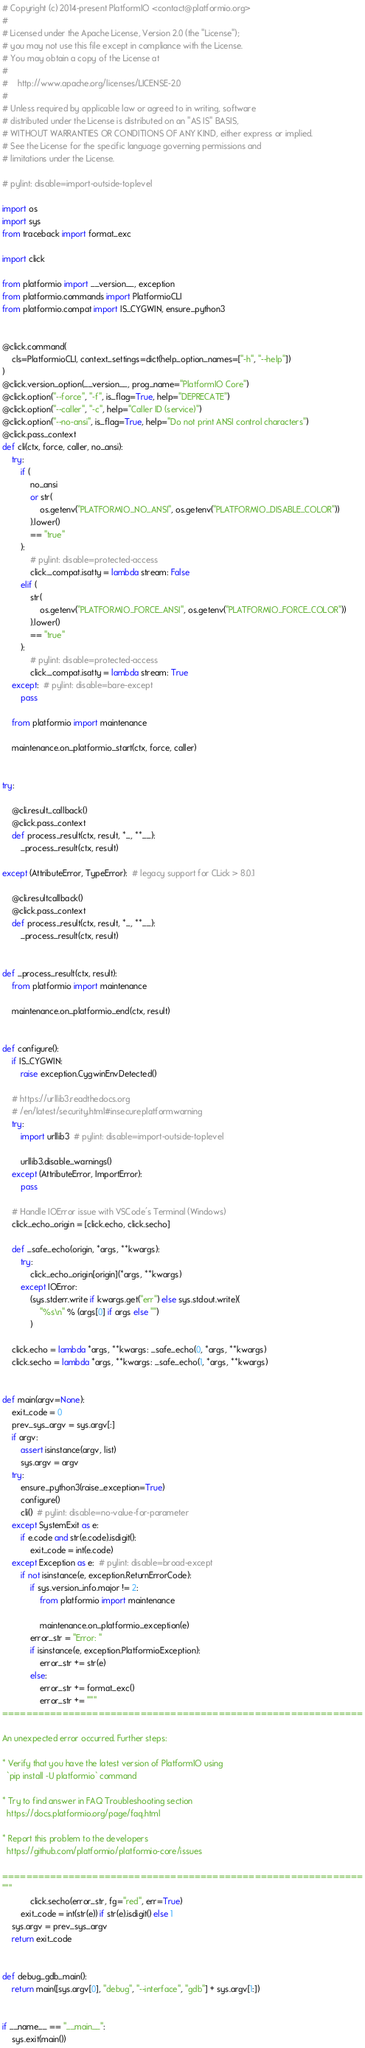<code> <loc_0><loc_0><loc_500><loc_500><_Python_># Copyright (c) 2014-present PlatformIO <contact@platformio.org>
#
# Licensed under the Apache License, Version 2.0 (the "License");
# you may not use this file except in compliance with the License.
# You may obtain a copy of the License at
#
#    http://www.apache.org/licenses/LICENSE-2.0
#
# Unless required by applicable law or agreed to in writing, software
# distributed under the License is distributed on an "AS IS" BASIS,
# WITHOUT WARRANTIES OR CONDITIONS OF ANY KIND, either express or implied.
# See the License for the specific language governing permissions and
# limitations under the License.

# pylint: disable=import-outside-toplevel

import os
import sys
from traceback import format_exc

import click

from platformio import __version__, exception
from platformio.commands import PlatformioCLI
from platformio.compat import IS_CYGWIN, ensure_python3


@click.command(
    cls=PlatformioCLI, context_settings=dict(help_option_names=["-h", "--help"])
)
@click.version_option(__version__, prog_name="PlatformIO Core")
@click.option("--force", "-f", is_flag=True, help="DEPRECATE")
@click.option("--caller", "-c", help="Caller ID (service)")
@click.option("--no-ansi", is_flag=True, help="Do not print ANSI control characters")
@click.pass_context
def cli(ctx, force, caller, no_ansi):
    try:
        if (
            no_ansi
            or str(
                os.getenv("PLATFORMIO_NO_ANSI", os.getenv("PLATFORMIO_DISABLE_COLOR"))
            ).lower()
            == "true"
        ):
            # pylint: disable=protected-access
            click._compat.isatty = lambda stream: False
        elif (
            str(
                os.getenv("PLATFORMIO_FORCE_ANSI", os.getenv("PLATFORMIO_FORCE_COLOR"))
            ).lower()
            == "true"
        ):
            # pylint: disable=protected-access
            click._compat.isatty = lambda stream: True
    except:  # pylint: disable=bare-except
        pass

    from platformio import maintenance

    maintenance.on_platformio_start(ctx, force, caller)


try:

    @cli.result_callback()
    @click.pass_context
    def process_result(ctx, result, *_, **__):
        _process_result(ctx, result)

except (AttributeError, TypeError):  # legacy support for CLick > 8.0.1

    @cli.resultcallback()
    @click.pass_context
    def process_result(ctx, result, *_, **__):
        _process_result(ctx, result)


def _process_result(ctx, result):
    from platformio import maintenance

    maintenance.on_platformio_end(ctx, result)


def configure():
    if IS_CYGWIN:
        raise exception.CygwinEnvDetected()

    # https://urllib3.readthedocs.org
    # /en/latest/security.html#insecureplatformwarning
    try:
        import urllib3  # pylint: disable=import-outside-toplevel

        urllib3.disable_warnings()
    except (AttributeError, ImportError):
        pass

    # Handle IOError issue with VSCode's Terminal (Windows)
    click_echo_origin = [click.echo, click.secho]

    def _safe_echo(origin, *args, **kwargs):
        try:
            click_echo_origin[origin](*args, **kwargs)
        except IOError:
            (sys.stderr.write if kwargs.get("err") else sys.stdout.write)(
                "%s\n" % (args[0] if args else "")
            )

    click.echo = lambda *args, **kwargs: _safe_echo(0, *args, **kwargs)
    click.secho = lambda *args, **kwargs: _safe_echo(1, *args, **kwargs)


def main(argv=None):
    exit_code = 0
    prev_sys_argv = sys.argv[:]
    if argv:
        assert isinstance(argv, list)
        sys.argv = argv
    try:
        ensure_python3(raise_exception=True)
        configure()
        cli()  # pylint: disable=no-value-for-parameter
    except SystemExit as e:
        if e.code and str(e.code).isdigit():
            exit_code = int(e.code)
    except Exception as e:  # pylint: disable=broad-except
        if not isinstance(e, exception.ReturnErrorCode):
            if sys.version_info.major != 2:
                from platformio import maintenance

                maintenance.on_platformio_exception(e)
            error_str = "Error: "
            if isinstance(e, exception.PlatformioException):
                error_str += str(e)
            else:
                error_str += format_exc()
                error_str += """
============================================================

An unexpected error occurred. Further steps:

* Verify that you have the latest version of PlatformIO using
  `pip install -U platformio` command

* Try to find answer in FAQ Troubleshooting section
  https://docs.platformio.org/page/faq.html

* Report this problem to the developers
  https://github.com/platformio/platformio-core/issues

============================================================
"""
            click.secho(error_str, fg="red", err=True)
        exit_code = int(str(e)) if str(e).isdigit() else 1
    sys.argv = prev_sys_argv
    return exit_code


def debug_gdb_main():
    return main([sys.argv[0], "debug", "--interface", "gdb"] + sys.argv[1:])


if __name__ == "__main__":
    sys.exit(main())
</code> 